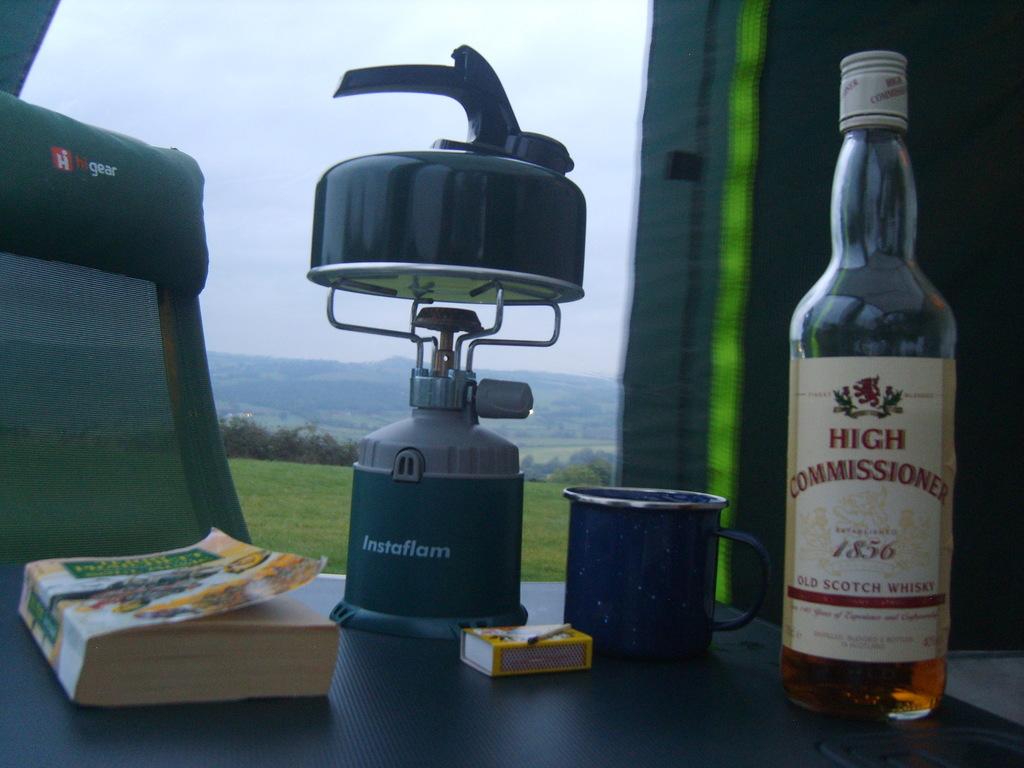What type of liquor is in the glass bottle?
Provide a short and direct response. Old scotch whiskey. 